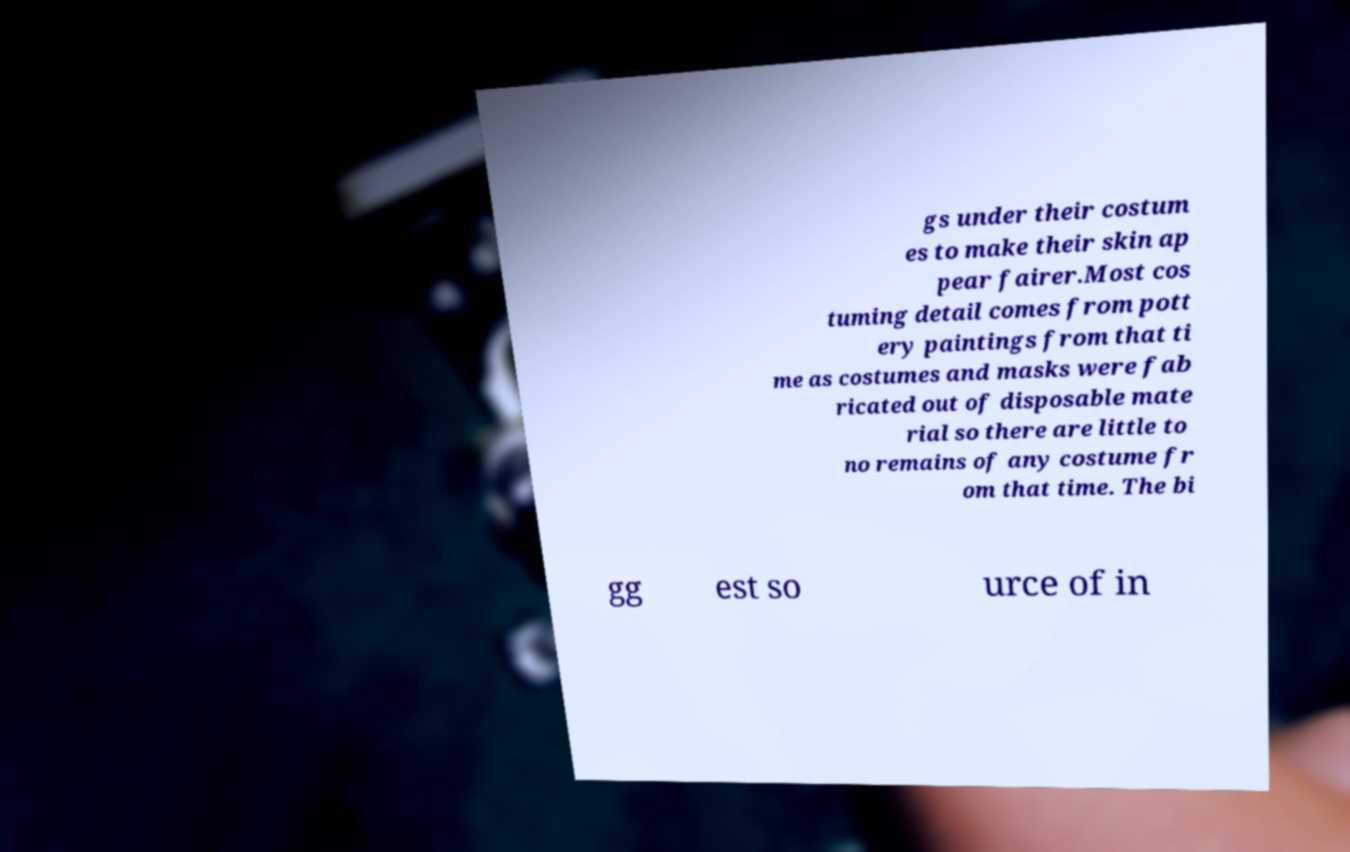What messages or text are displayed in this image? I need them in a readable, typed format. gs under their costum es to make their skin ap pear fairer.Most cos tuming detail comes from pott ery paintings from that ti me as costumes and masks were fab ricated out of disposable mate rial so there are little to no remains of any costume fr om that time. The bi gg est so urce of in 